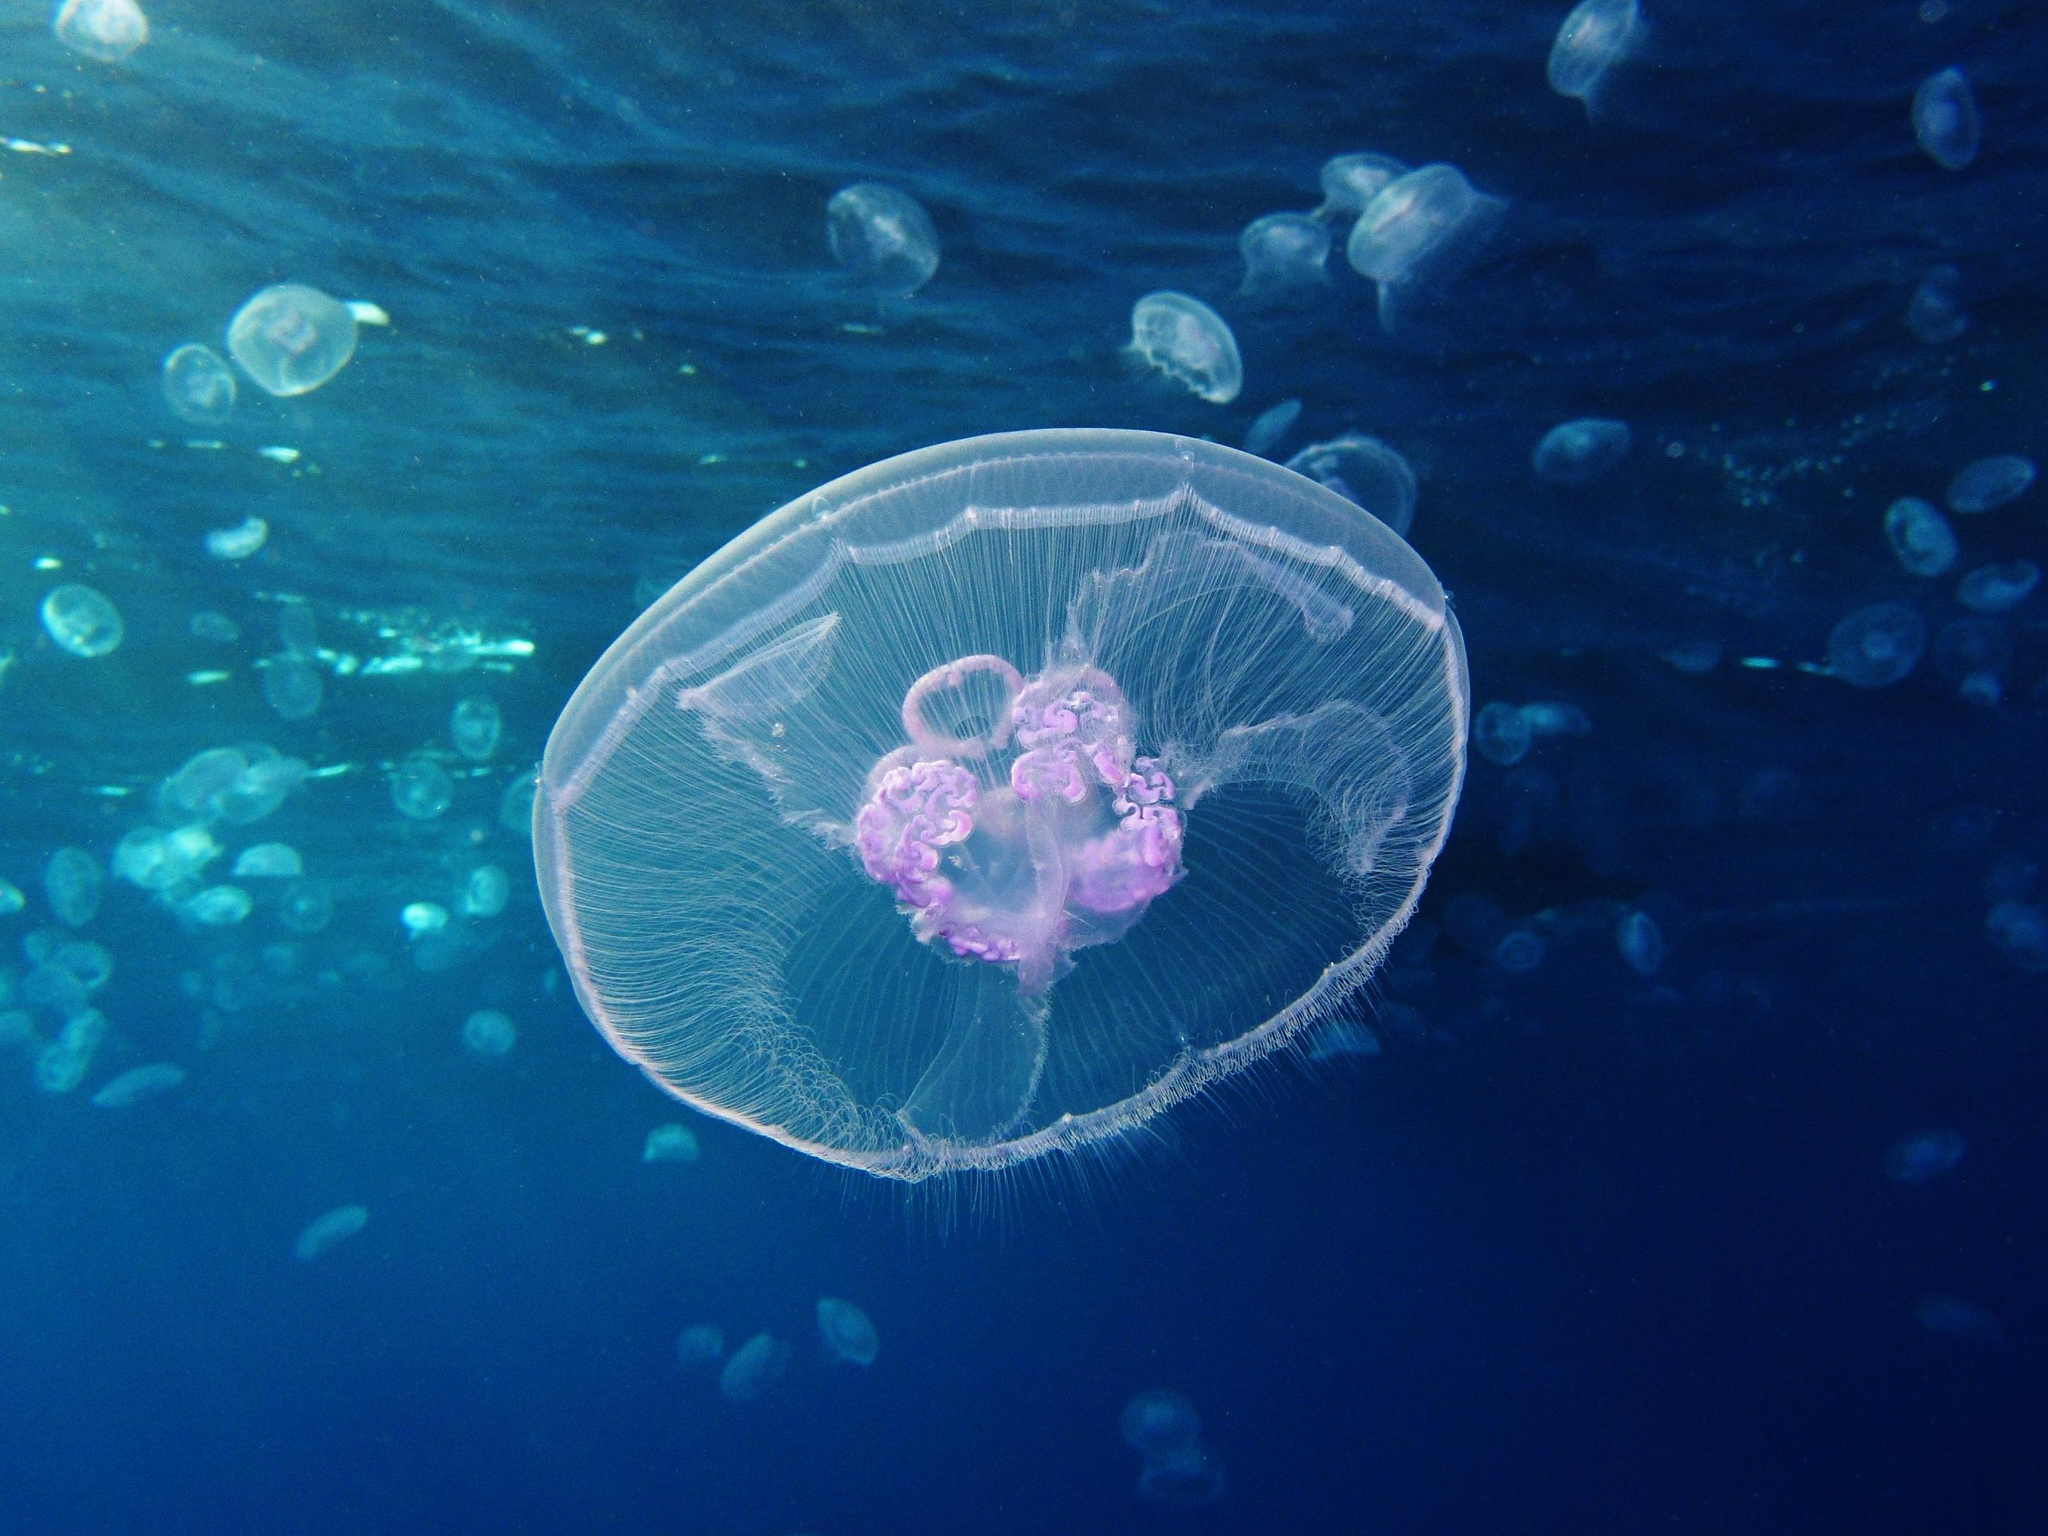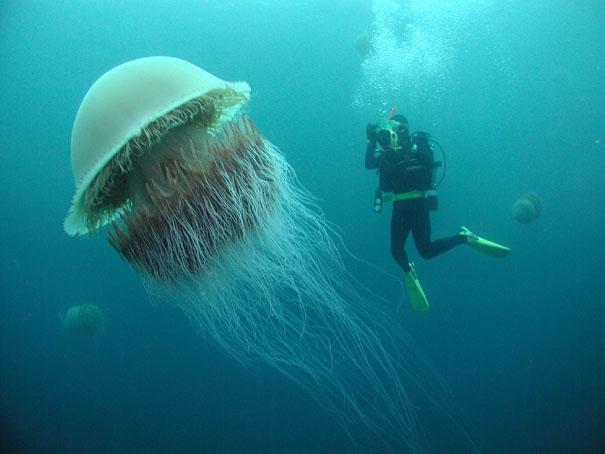The first image is the image on the left, the second image is the image on the right. For the images shown, is this caption "The right image shows at least one vivid orange jellyfish." true? Answer yes or no. No. 